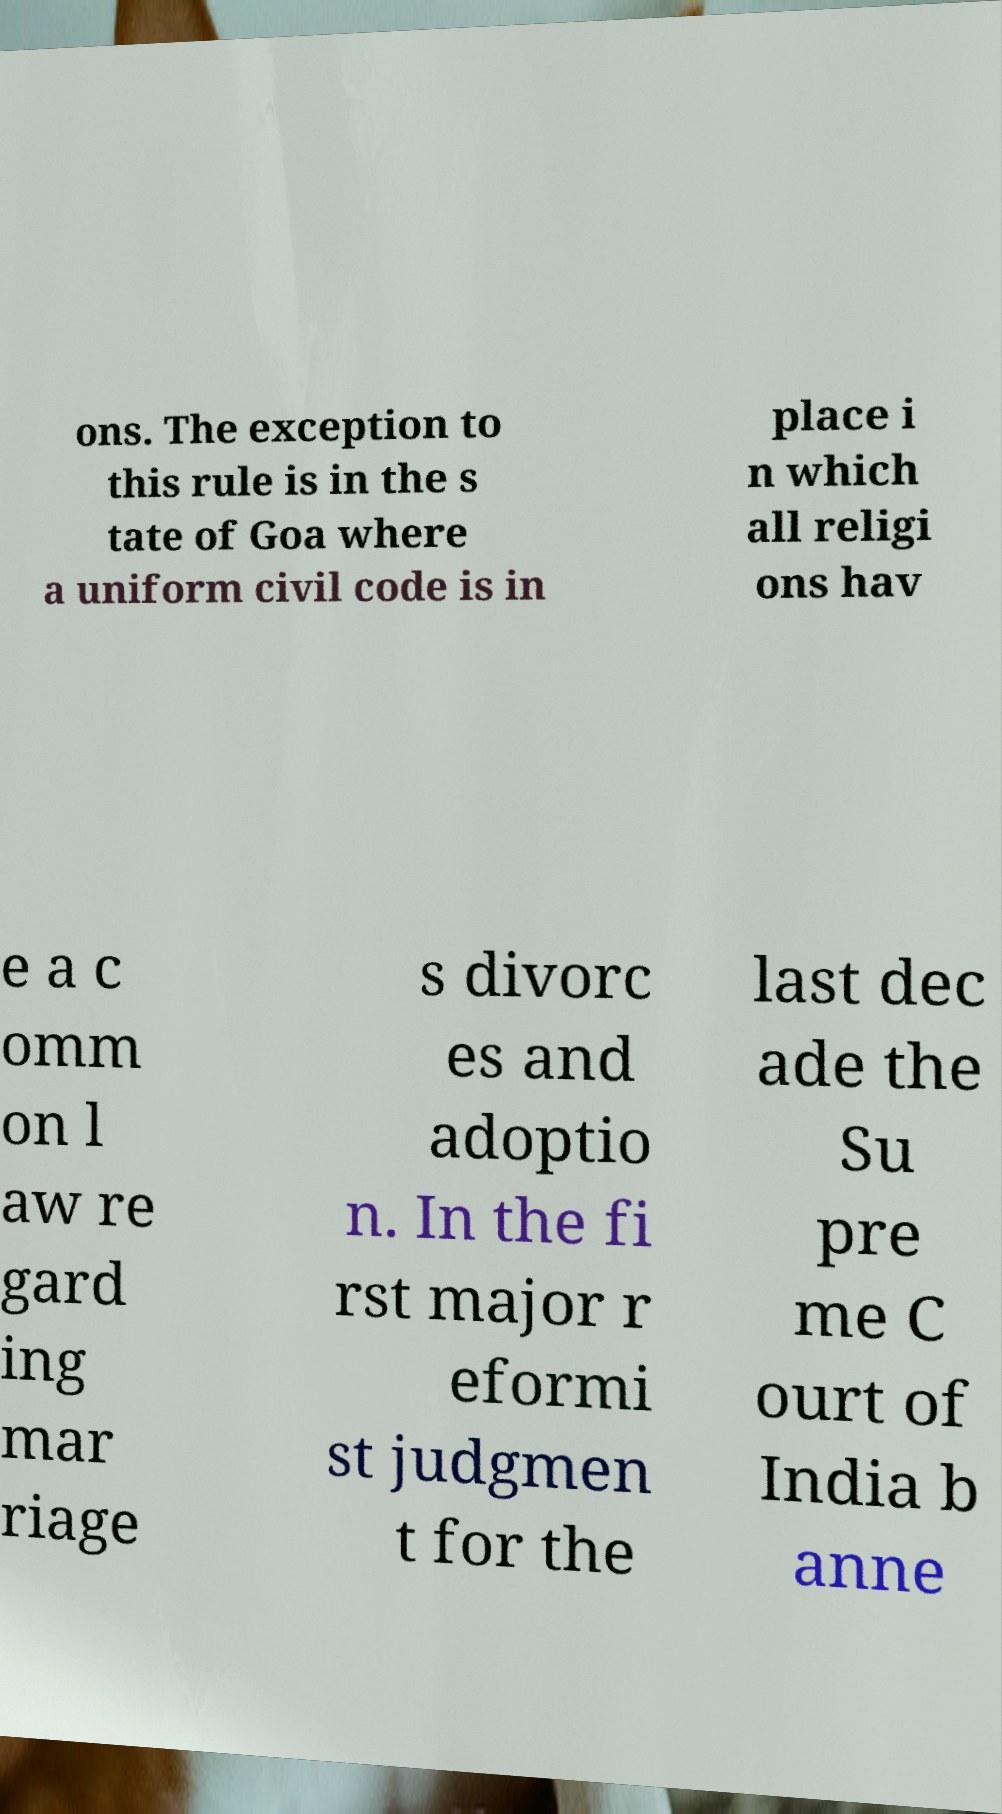Could you assist in decoding the text presented in this image and type it out clearly? ons. The exception to this rule is in the s tate of Goa where a uniform civil code is in place i n which all religi ons hav e a c omm on l aw re gard ing mar riage s divorc es and adoptio n. In the fi rst major r eformi st judgmen t for the last dec ade the Su pre me C ourt of India b anne 